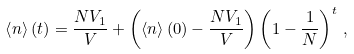<formula> <loc_0><loc_0><loc_500><loc_500>\left < n \right > ( t ) = \frac { N V _ { 1 } } { V } + \left ( \left < n \right > ( 0 ) - \frac { N V _ { 1 } } { V } \right ) \left ( 1 - \frac { 1 } { N } \right ) ^ { t } \, ,</formula> 